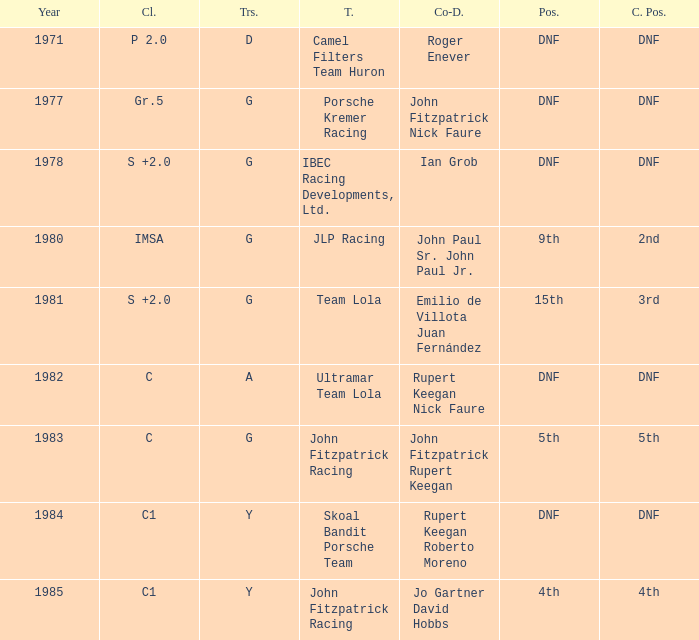Which tires were in Class C in years before 1983? A. 